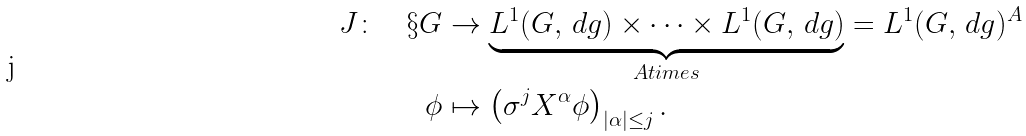<formula> <loc_0><loc_0><loc_500><loc_500>J \colon \quad \S G & \to \underbrace { L ^ { 1 } ( G , \, d g ) \times \dots \times L ^ { 1 } ( G , \, d g ) } _ { A t i m e s } = L ^ { 1 } ( G , \, d g ) ^ { A } \\ \phi & \mapsto \left ( \sigma ^ { j } X ^ { \alpha } \phi \right ) _ { | \alpha | \leq j } .</formula> 